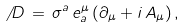<formula> <loc_0><loc_0><loc_500><loc_500>\not \, D \, = \, \sigma ^ { a } \, e ^ { \mu } _ { a } \, ( \partial _ { \mu } + i \, A _ { \mu } ) \, ,</formula> 